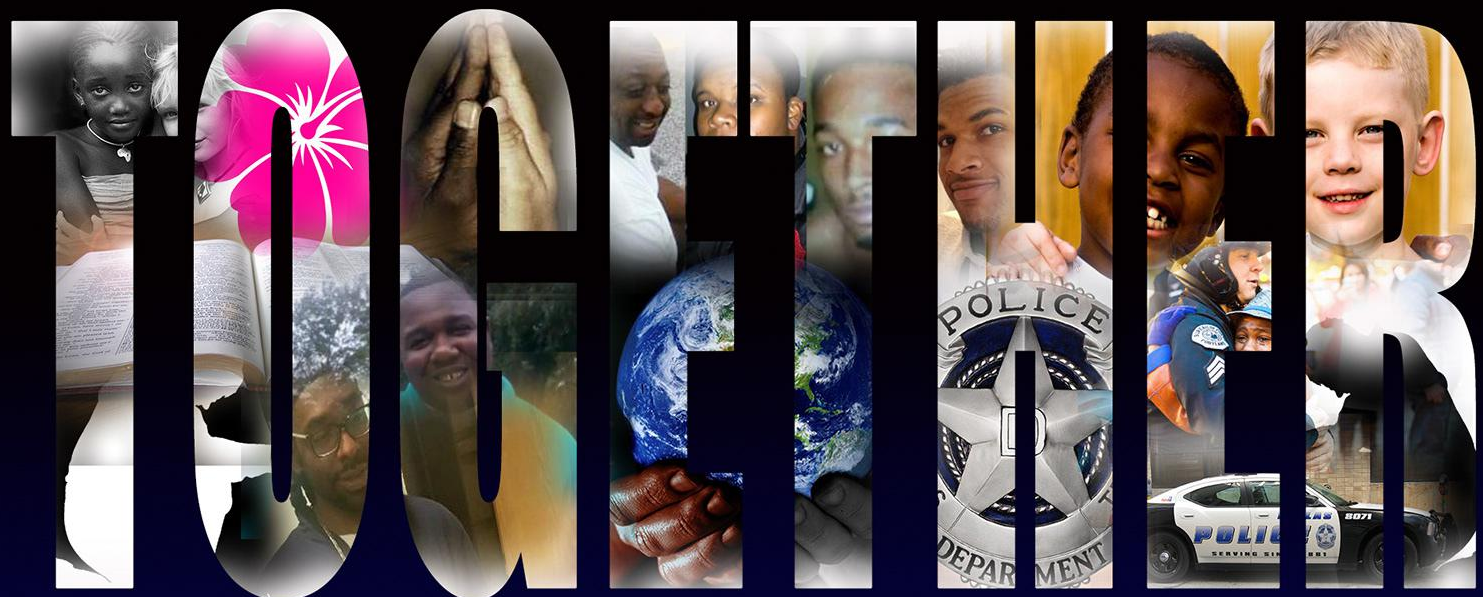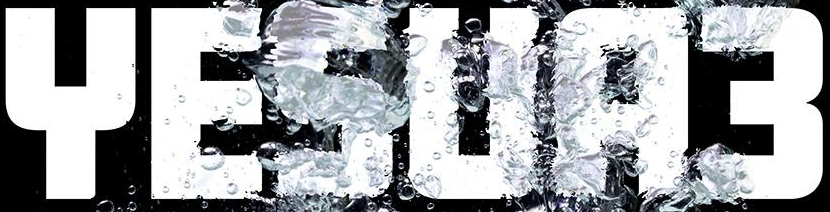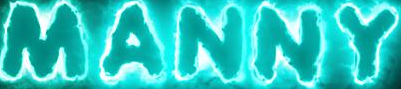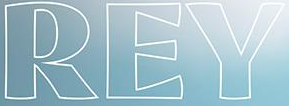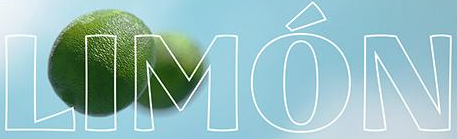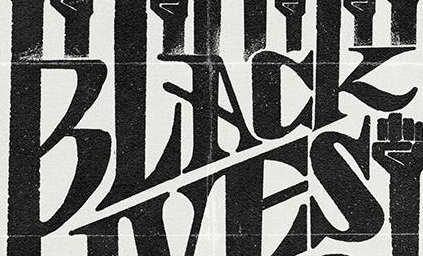Transcribe the words shown in these images in order, separated by a semicolon. TOGETHER; YESUA3; MANNY; REY; LIMÓN; BLACK 